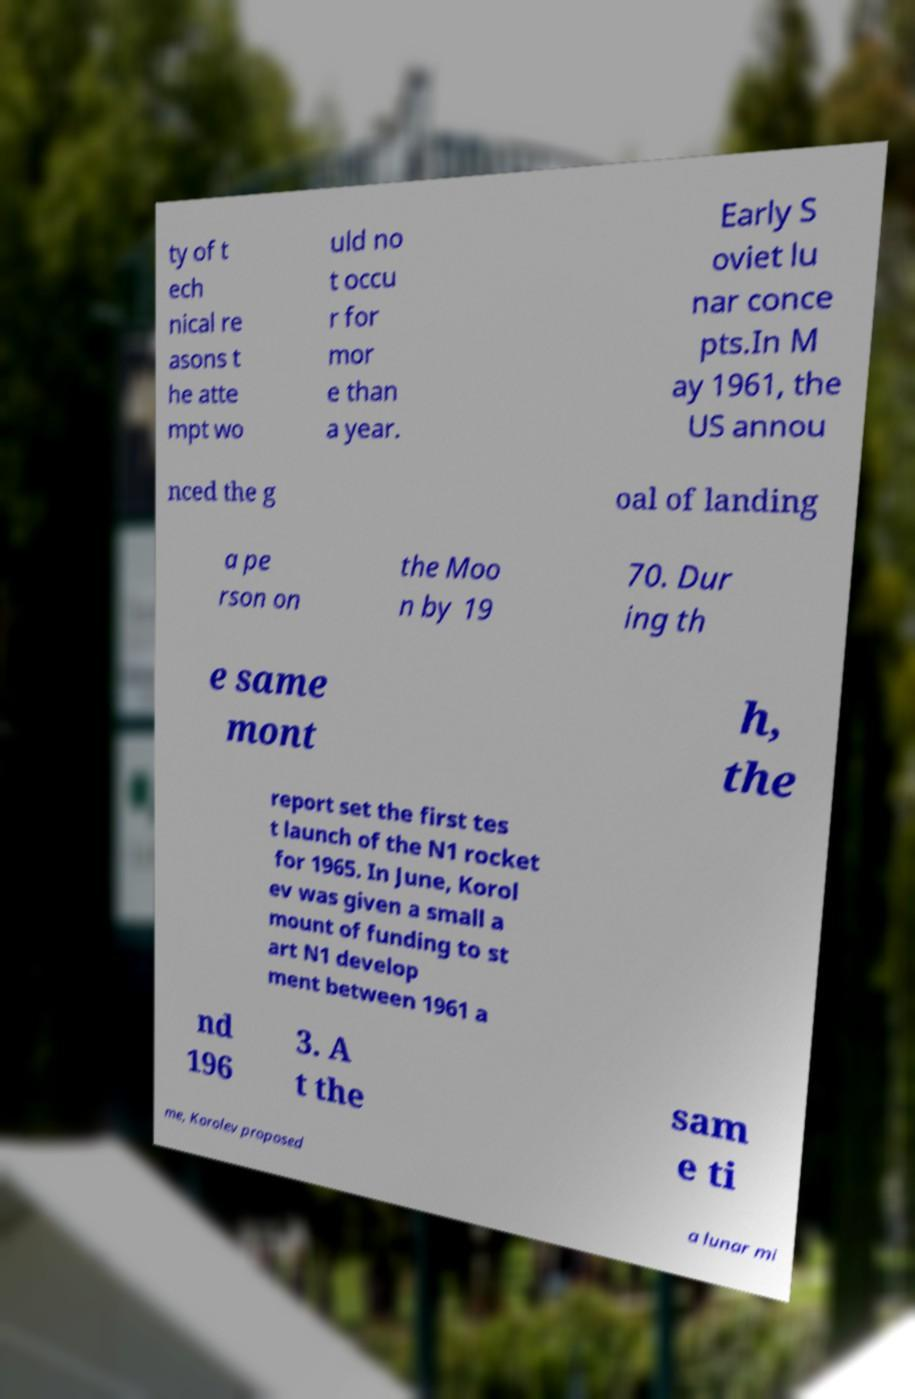I need the written content from this picture converted into text. Can you do that? ty of t ech nical re asons t he atte mpt wo uld no t occu r for mor e than a year. Early S oviet lu nar conce pts.In M ay 1961, the US annou nced the g oal of landing a pe rson on the Moo n by 19 70. Dur ing th e same mont h, the report set the first tes t launch of the N1 rocket for 1965. In June, Korol ev was given a small a mount of funding to st art N1 develop ment between 1961 a nd 196 3. A t the sam e ti me, Korolev proposed a lunar mi 